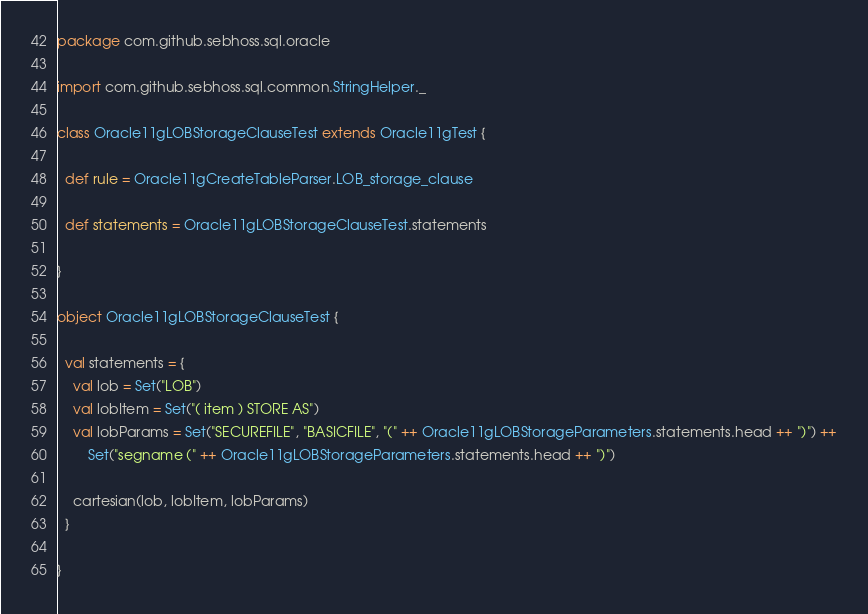Convert code to text. <code><loc_0><loc_0><loc_500><loc_500><_Scala_>package com.github.sebhoss.sql.oracle

import com.github.sebhoss.sql.common.StringHelper._

class Oracle11gLOBStorageClauseTest extends Oracle11gTest {

  def rule = Oracle11gCreateTableParser.LOB_storage_clause

  def statements = Oracle11gLOBStorageClauseTest.statements

}

object Oracle11gLOBStorageClauseTest {

  val statements = {
    val lob = Set("LOB")
    val lobItem = Set("( item ) STORE AS")
    val lobParams = Set("SECUREFILE", "BASICFILE", "(" ++ Oracle11gLOBStorageParameters.statements.head ++ ")") ++
    	Set("segname (" ++ Oracle11gLOBStorageParameters.statements.head ++ ")")

    cartesian(lob, lobItem, lobParams)
  }

}</code> 